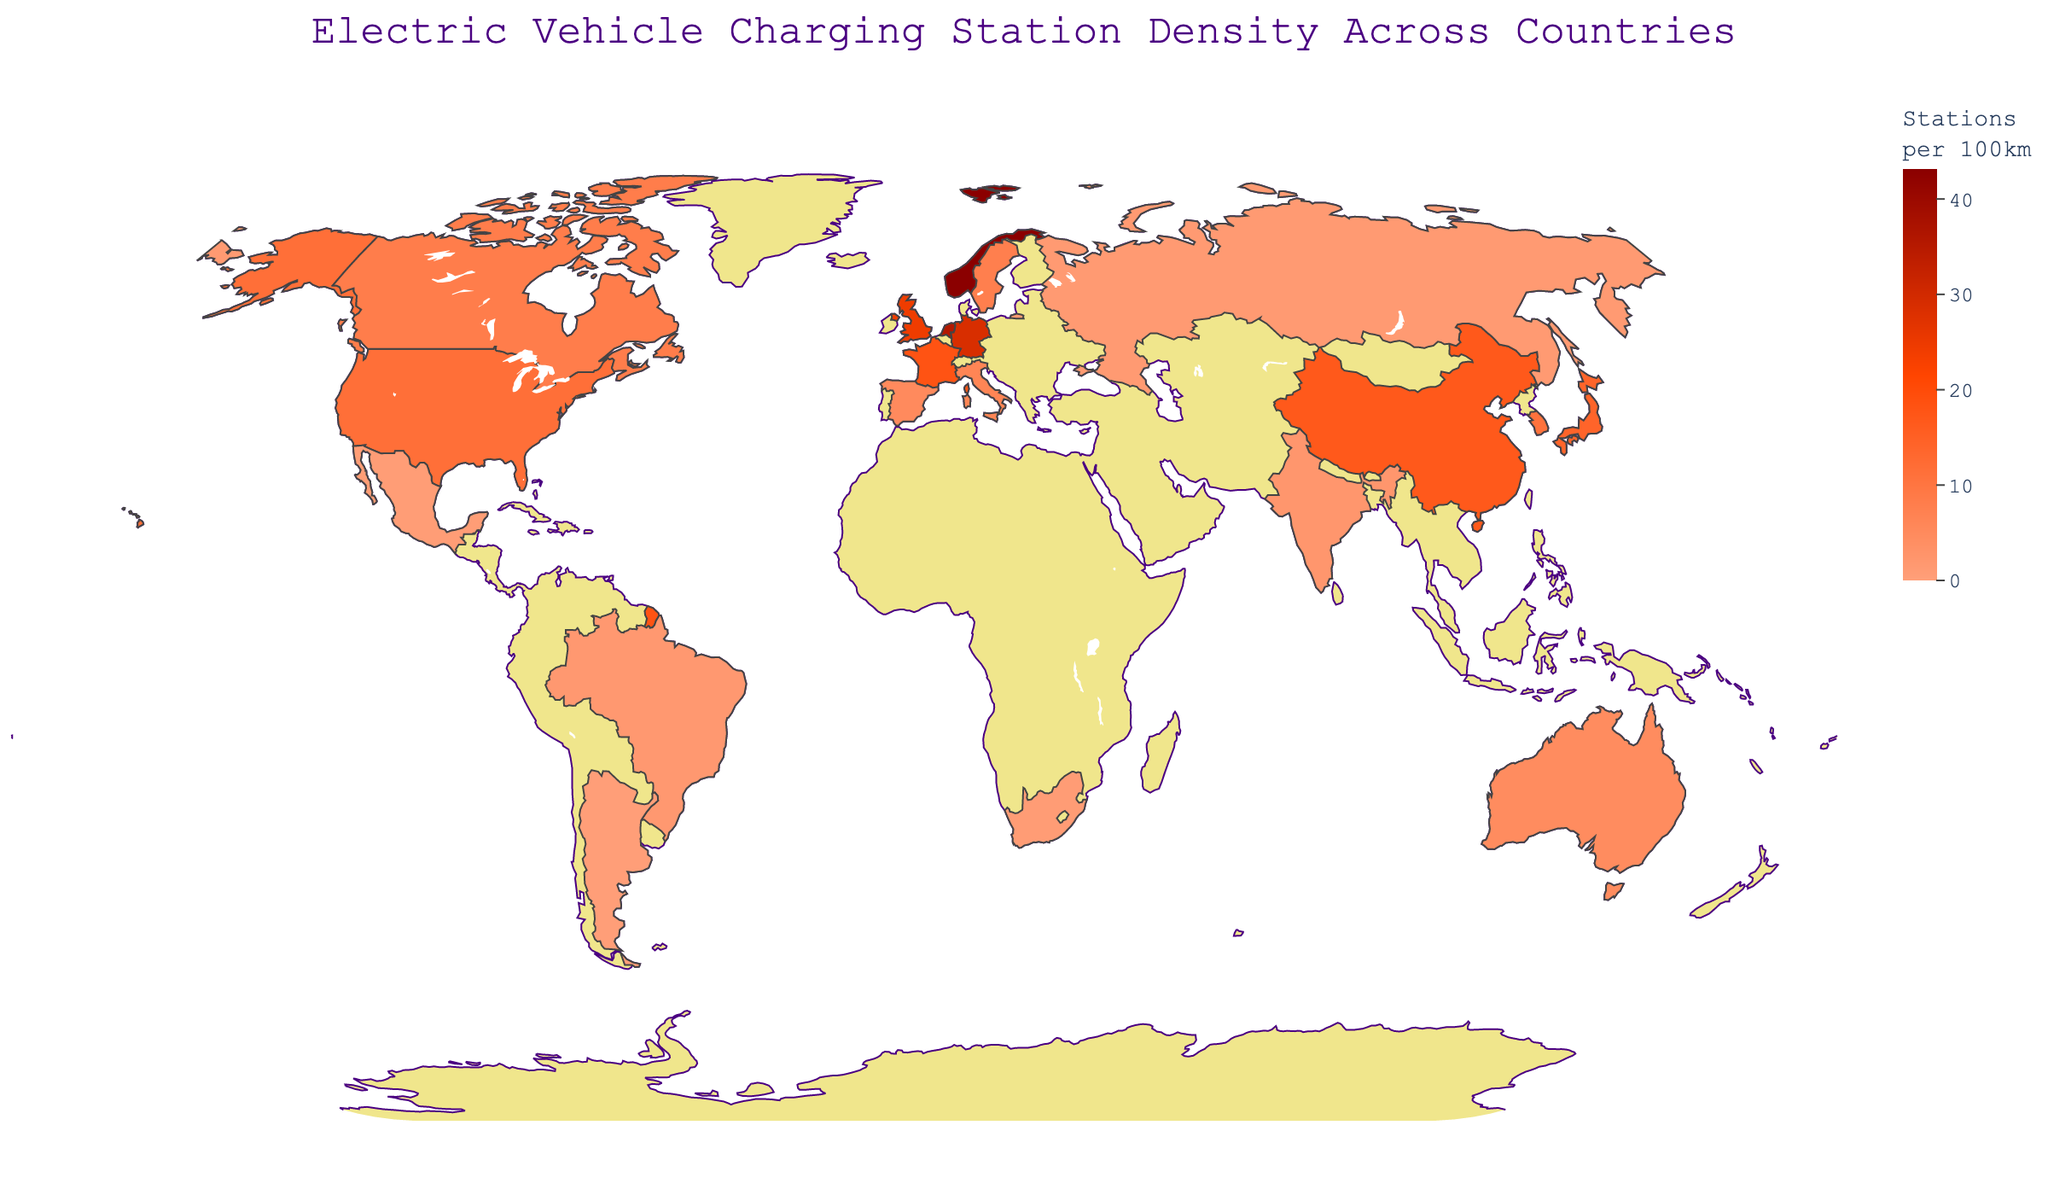what is the title of the figure? The title is located at the top center of the figure. It indicates what the graph is about.
Answer: Electric Vehicle Charging Station Density Across Countries Which country has the highest density of electric vehicle charging stations? Identify the color representing the highest density on the color scale, then locate the country with this color on the map.
Answer: Norway Which country has fewer electric vehicle charging stations per 100 km, Australia or Spain? Compare the values for Australia and Spain from the data. Australia is mapped in a lighter color compared to Spain.
Answer: Australia What's the density range of electric vehicle charging stations displayed on the color scale? Refer to the color scale on the right side of the plot to find the minimum and maximum values.
Answer: 0 to 43.2 How does the density of charging stations in Japan compare to that in Brazil? Locate Japan and Brazil on the map and compare the represented densities. Japan has higher density than Brazil.
Answer: Japan has a higher density What is the median density value among the countries shown? To find the median, list all densities in numerical order and find the middle value. For an even number of countries, average the two middle values.
Answer: 10.9 Which region (continent) seems to have the most uniformly high density of electric vehicle charging stations? Observe the densities shown in different parts of the world. Europe shows more uniformly high densities as compared to other regions.
Answer: Europe What feature helps differentiate land and water in the figure? The color distinction between land and ocean is used to differentiate them, with land in yellowish color, and water in light blue.
Answer: Color distinction Do South Korea and Mexico have similar densities of charging stations? Compare the densities of South Korea and Mexico from the map and data. South Korea has a significantly higher density than Mexico.
Answer: No How many countries have a density of electric vehicle charging stations above 20 per 100 km? Identify and count the countries with densities above 20 from the data list.
Answer: Four (Norway, Netherlands, Germany, United Kingdom) Is there a visible trend between the countries with higher densities in terms of their geographical location? Observe the countries with higher densities and their locations on the map. Most countries with higher densities are in Europe.
Answer: Yes 